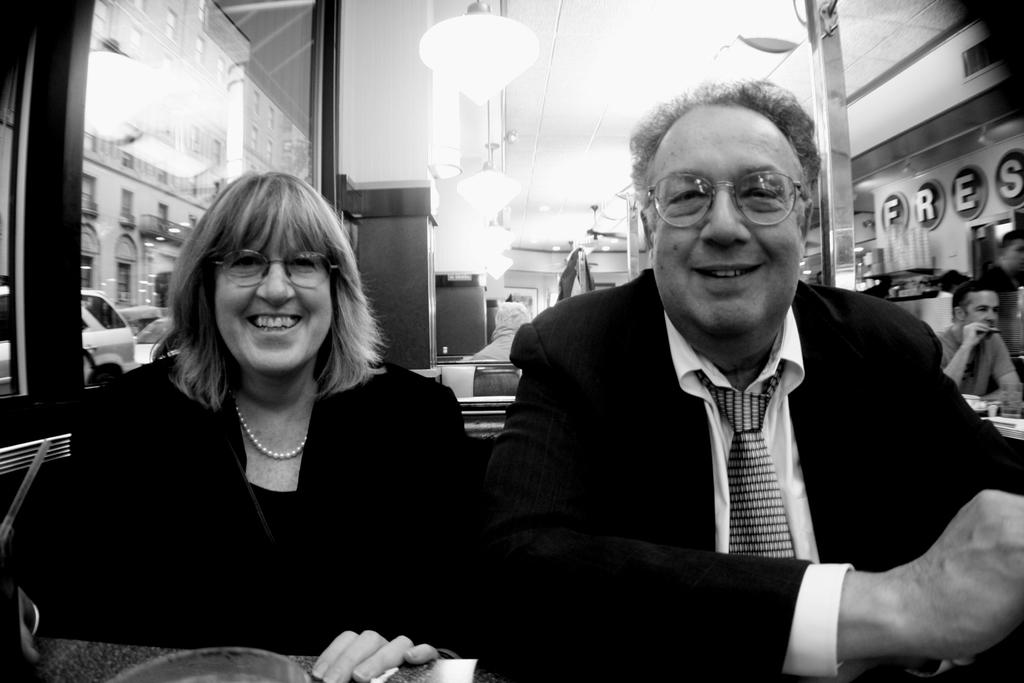What is the color scheme of the image? The image is black and white. How many people are in the image? There are two persons in the image. Can you describe the gender of the persons? One of the persons is a man, and the other person is a woman. What is located at the top of the image? There are lights at the top of the image. What type of vegetable is being accounted for during the voyage in the image? There is no vegetable, account, or voyage present in the image. 